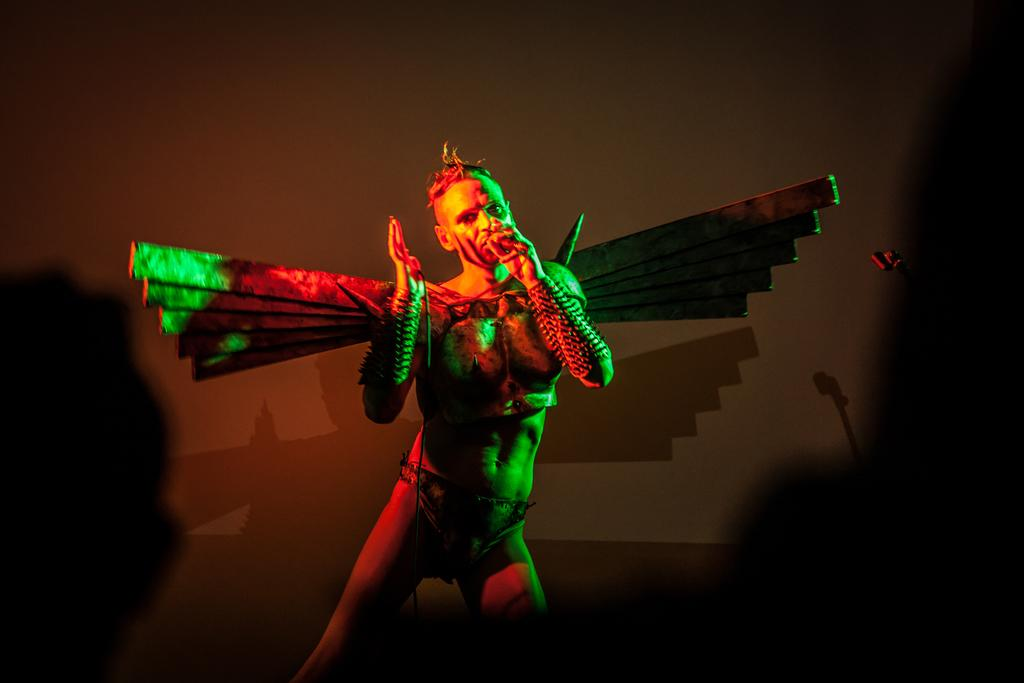What is the main subject of the image? There is a person in the image. What is the person wearing? The person is wearing a different costume. Can you describe the background of the image? The background of the image is dark. What type of animal can be seen in the scene depicted in the image? There is no animal present in the image; it features a person wearing a different costume against a dark background. 